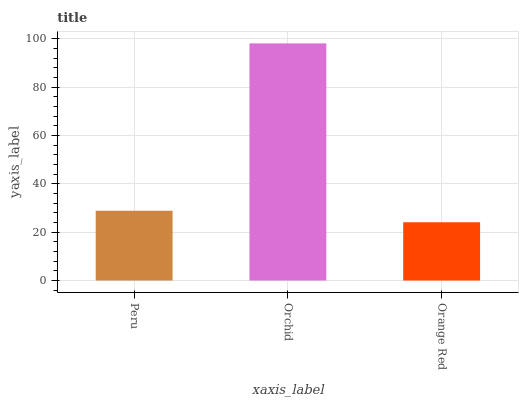Is Orange Red the minimum?
Answer yes or no. Yes. Is Orchid the maximum?
Answer yes or no. Yes. Is Orchid the minimum?
Answer yes or no. No. Is Orange Red the maximum?
Answer yes or no. No. Is Orchid greater than Orange Red?
Answer yes or no. Yes. Is Orange Red less than Orchid?
Answer yes or no. Yes. Is Orange Red greater than Orchid?
Answer yes or no. No. Is Orchid less than Orange Red?
Answer yes or no. No. Is Peru the high median?
Answer yes or no. Yes. Is Peru the low median?
Answer yes or no. Yes. Is Orchid the high median?
Answer yes or no. No. Is Orange Red the low median?
Answer yes or no. No. 